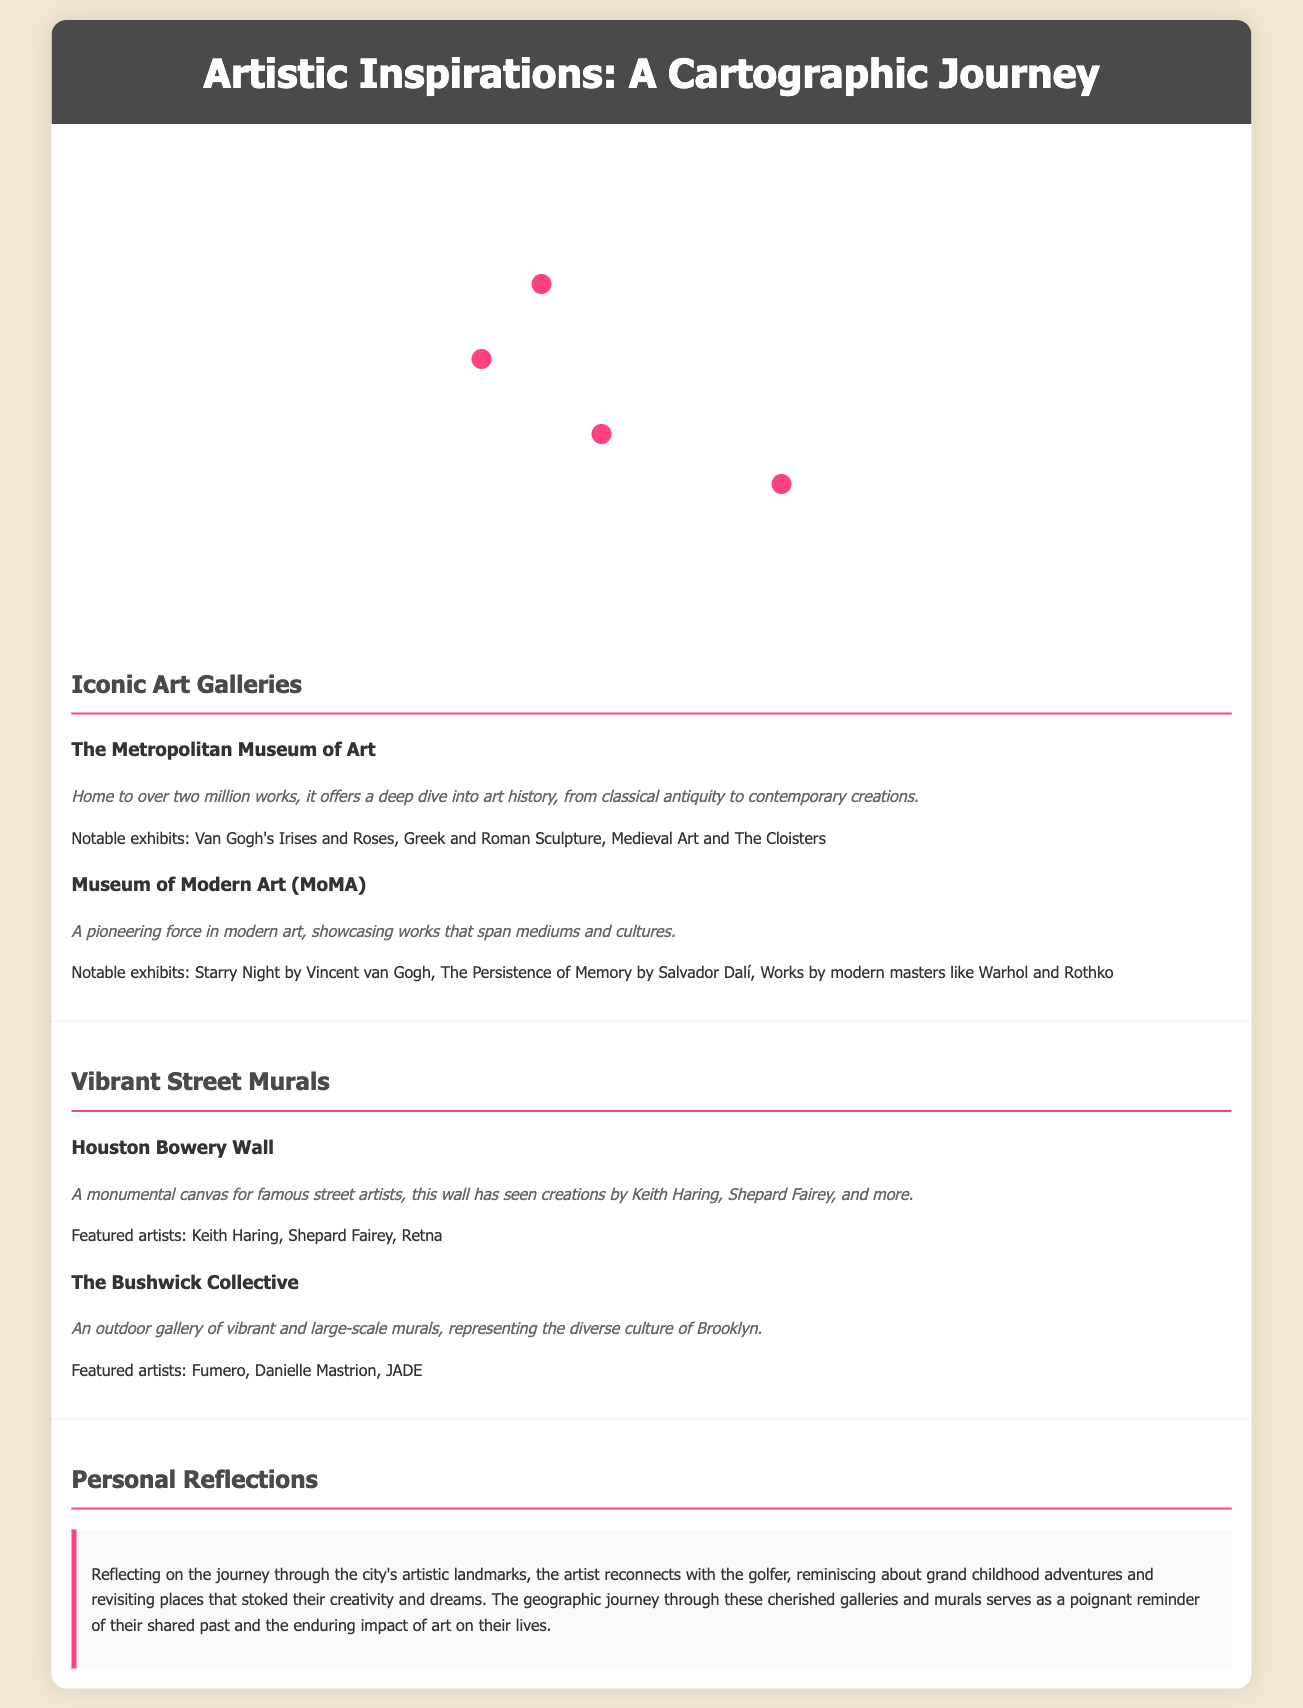What is the address of The Metropolitan Museum of Art? The address of The Metropolitan Museum of Art is provided in the document.
Answer: 1000 5th Ave, New York, NY 10028 Who is the featured artist at the Houston Bowery Wall? The document lists prominent artists who have worked on the Houston Bowery Wall.
Answer: Keith Haring What notable exhibit is displayed at MoMA? Notable exhibitions for each gallery are mentioned, pointing to a specific work showcased at MoMA.
Answer: Starry Night by Vincent van Gogh How many works are housed at The Metropolitan Museum of Art? The document states the number of works in The Metropolitan Museum of Art.
Answer: Over two million works What type of art is primarily exhibited at the Bushwick Collective? The document describes the nature of the murals at the Bushwick Collective reflecting on the diversity of culture.
Answer: Vibrant and large-scale murals Which museum showcases The Persistence of Memory? The notable exhibits section will help identify the museum where The Persistence of Memory is displayed.
Answer: Museum of Modern Art (MoMA) What percentage of the map marker for The Bushwick Collective is positioned at the top? The document provides the specific vertical position of the map marker for the Bushwick Collective.
Answer: 70% What is the theme of the personal reflections section? The personal reflections provide insights into the artist's reminiscence and connection to childhood adventures.
Answer: Shared past and artistic impact 